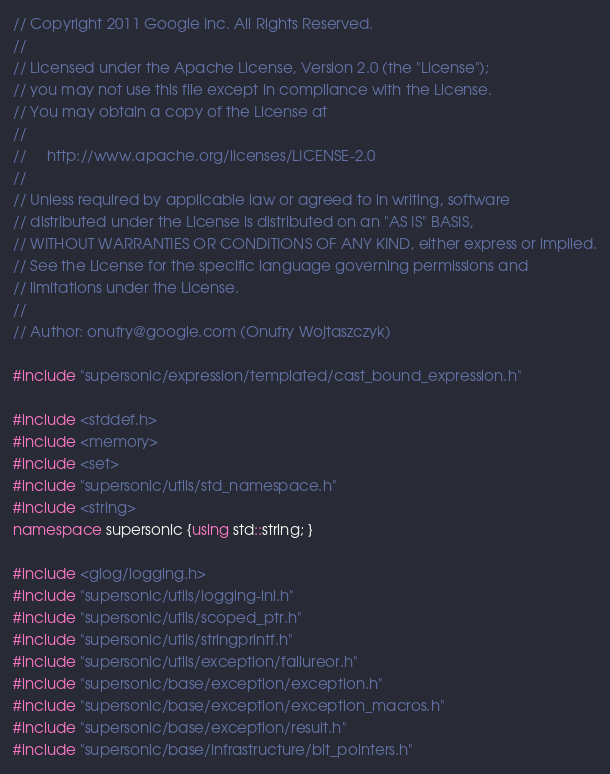Convert code to text. <code><loc_0><loc_0><loc_500><loc_500><_C++_>// Copyright 2011 Google Inc. All Rights Reserved.
//
// Licensed under the Apache License, Version 2.0 (the "License");
// you may not use this file except in compliance with the License.
// You may obtain a copy of the License at
//
//     http://www.apache.org/licenses/LICENSE-2.0
//
// Unless required by applicable law or agreed to in writing, software
// distributed under the License is distributed on an "AS IS" BASIS,
// WITHOUT WARRANTIES OR CONDITIONS OF ANY KIND, either express or implied.
// See the License for the specific language governing permissions and
// limitations under the License.
//
// Author: onufry@google.com (Onufry Wojtaszczyk)

#include "supersonic/expression/templated/cast_bound_expression.h"

#include <stddef.h>
#include <memory>
#include <set>
#include "supersonic/utils/std_namespace.h"
#include <string>
namespace supersonic {using std::string; }

#include <glog/logging.h>
#include "supersonic/utils/logging-inl.h"
#include "supersonic/utils/scoped_ptr.h"
#include "supersonic/utils/stringprintf.h"
#include "supersonic/utils/exception/failureor.h"
#include "supersonic/base/exception/exception.h"
#include "supersonic/base/exception/exception_macros.h"
#include "supersonic/base/exception/result.h"
#include "supersonic/base/infrastructure/bit_pointers.h"</code> 